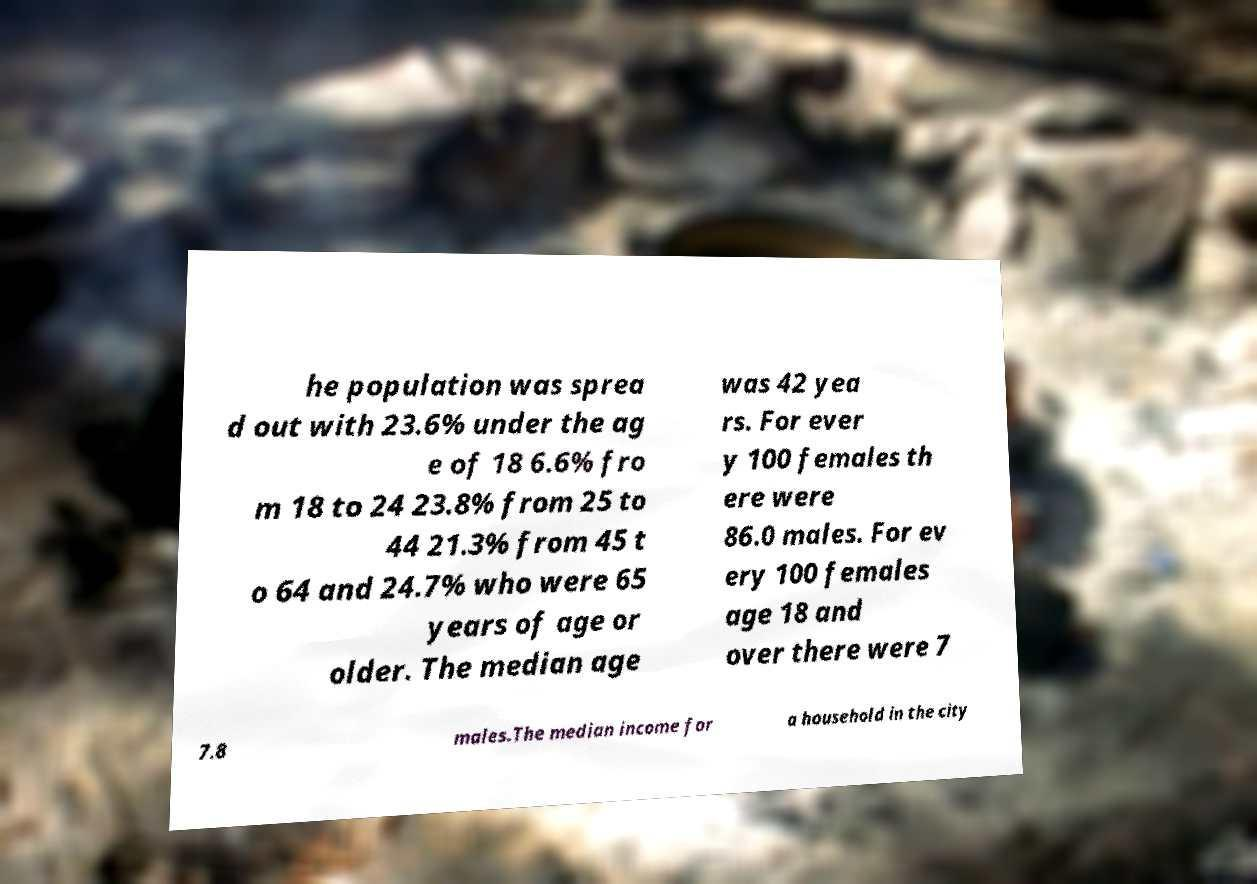Can you accurately transcribe the text from the provided image for me? he population was sprea d out with 23.6% under the ag e of 18 6.6% fro m 18 to 24 23.8% from 25 to 44 21.3% from 45 t o 64 and 24.7% who were 65 years of age or older. The median age was 42 yea rs. For ever y 100 females th ere were 86.0 males. For ev ery 100 females age 18 and over there were 7 7.8 males.The median income for a household in the city 